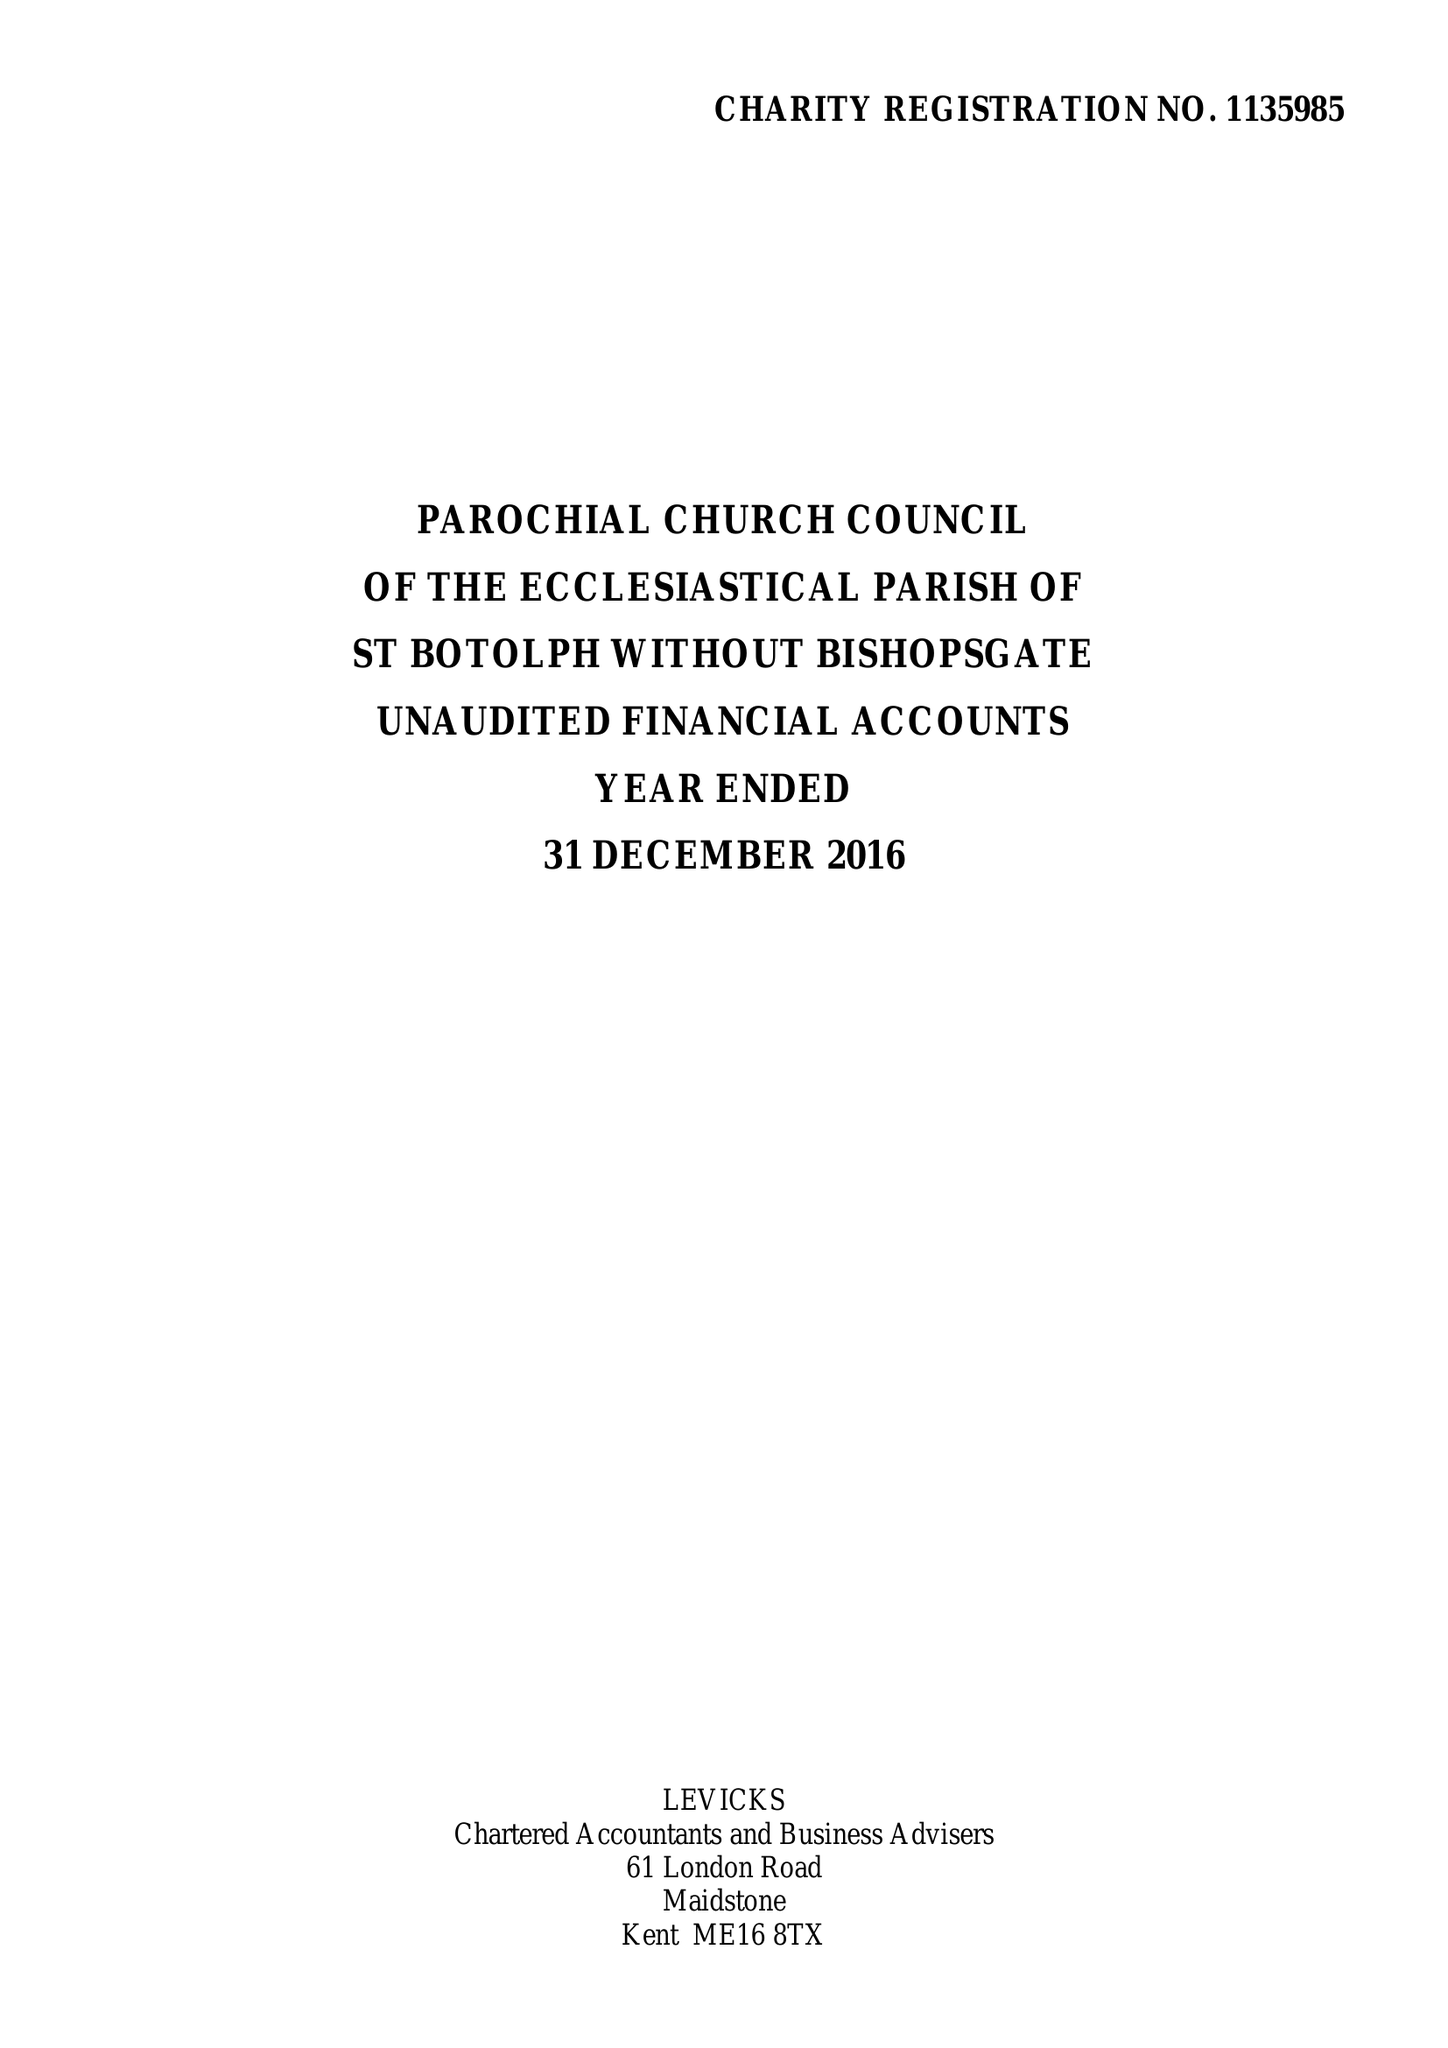What is the value for the charity_number?
Answer the question using a single word or phrase. 1135985 